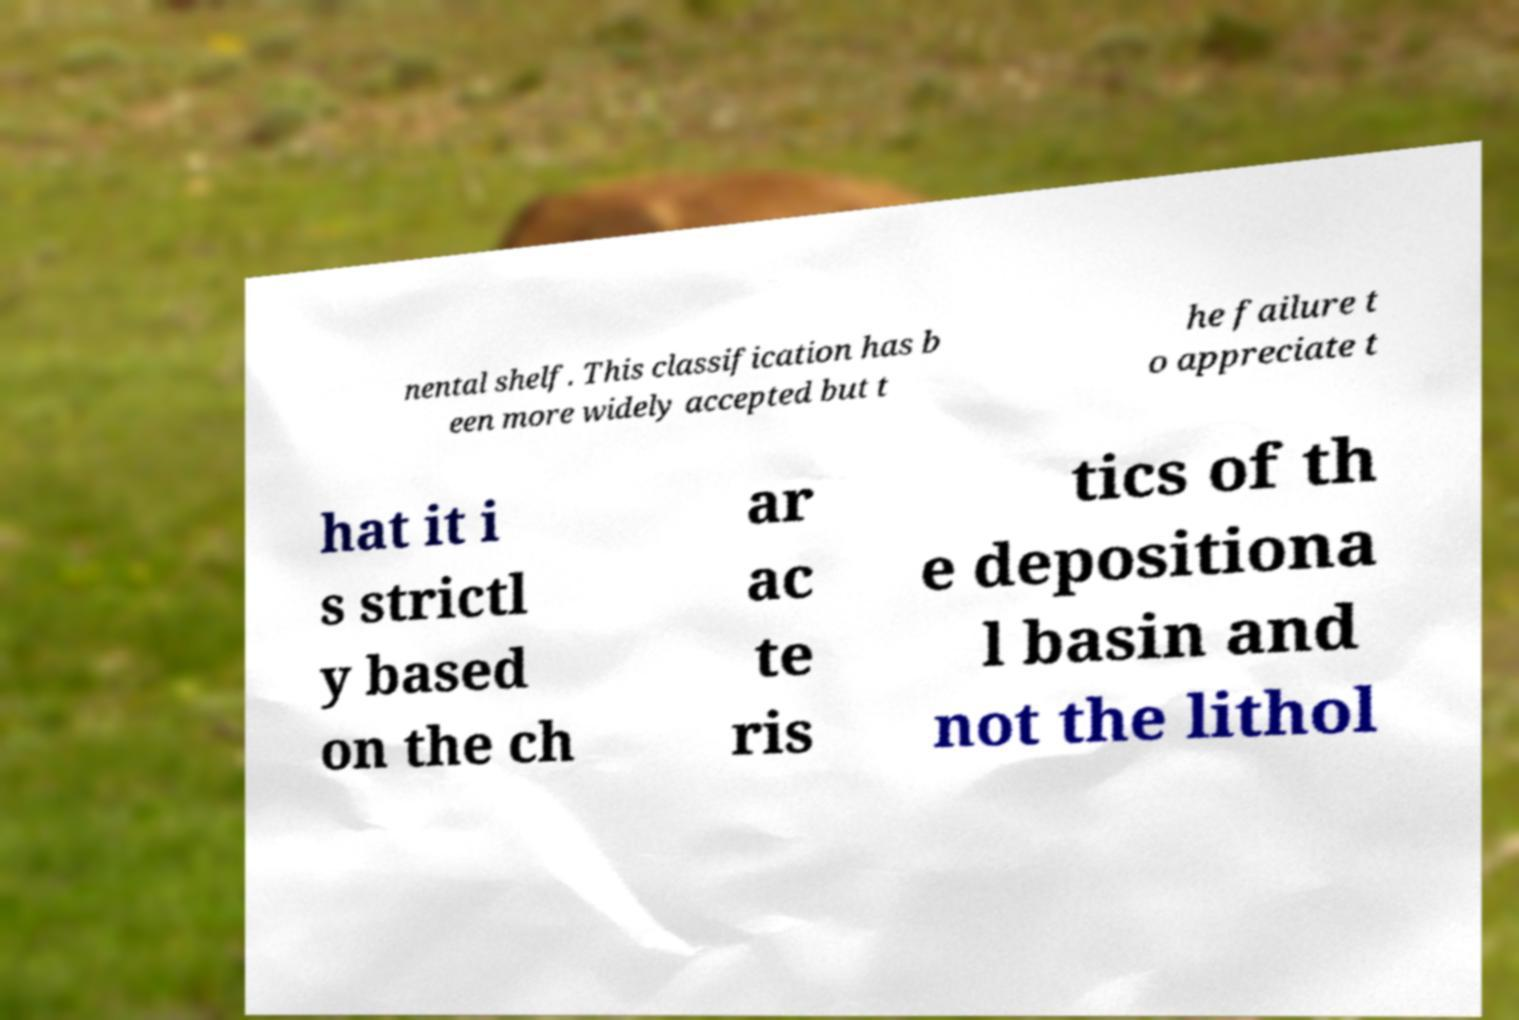Please identify and transcribe the text found in this image. nental shelf. This classification has b een more widely accepted but t he failure t o appreciate t hat it i s strictl y based on the ch ar ac te ris tics of th e depositiona l basin and not the lithol 